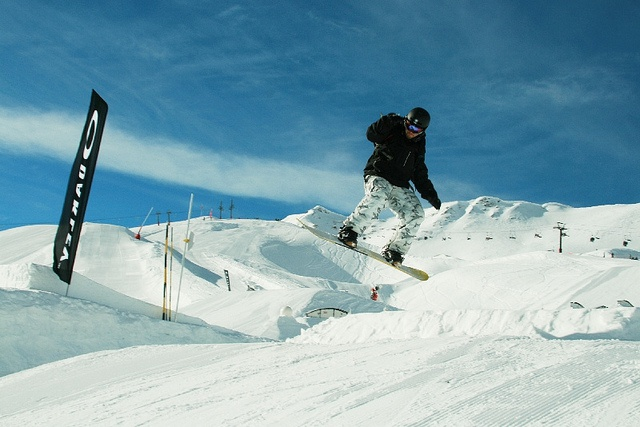Describe the objects in this image and their specific colors. I can see people in teal, black, darkgray, gray, and lightgray tones, snowboard in teal, darkgray, olive, and gray tones, and snowboard in teal, darkgray, lightgray, gray, and black tones in this image. 